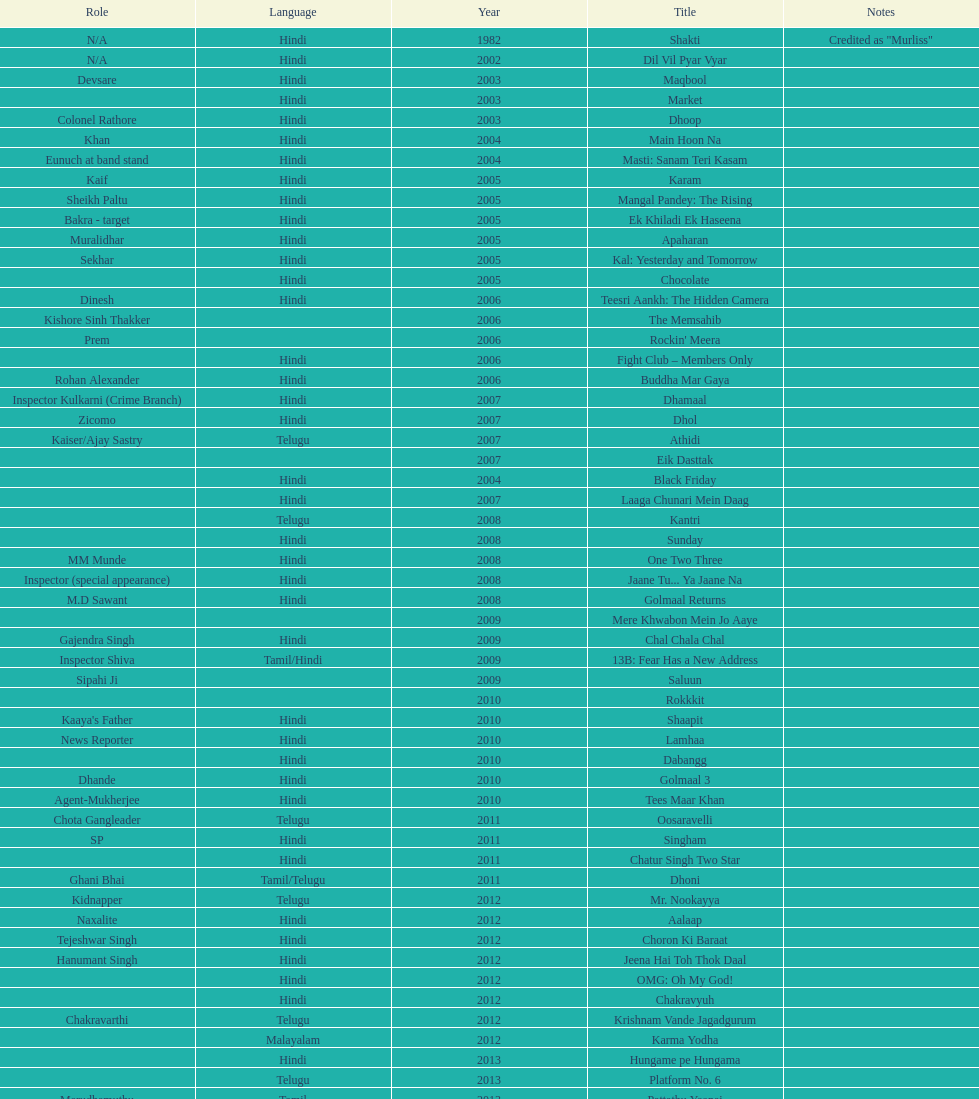How many roles has this actor had? 36. 